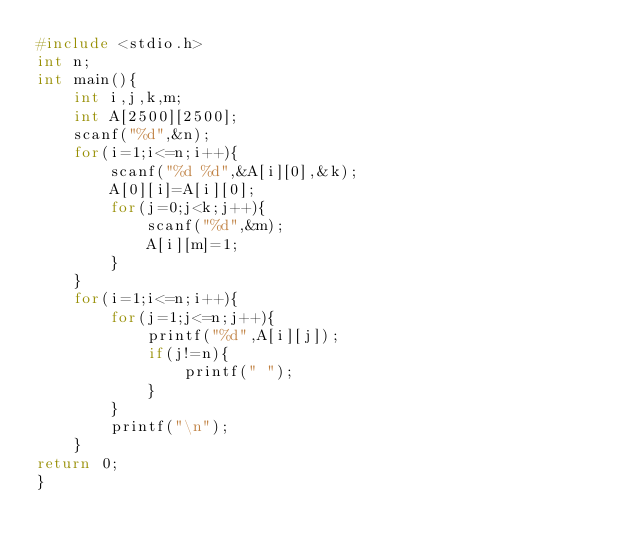Convert code to text. <code><loc_0><loc_0><loc_500><loc_500><_C_>#include <stdio.h>
int n;
int main(){
    int i,j,k,m;
    int A[2500][2500];
    scanf("%d",&n);
    for(i=1;i<=n;i++){
        scanf("%d %d",&A[i][0],&k);
        A[0][i]=A[i][0];
        for(j=0;j<k;j++){
            scanf("%d",&m);
            A[i][m]=1;
        }
    }
    for(i=1;i<=n;i++){
        for(j=1;j<=n;j++){
            printf("%d",A[i][j]);
            if(j!=n){
                printf(" ");
            }
        }
        printf("\n");
    }
return 0;
}
</code> 